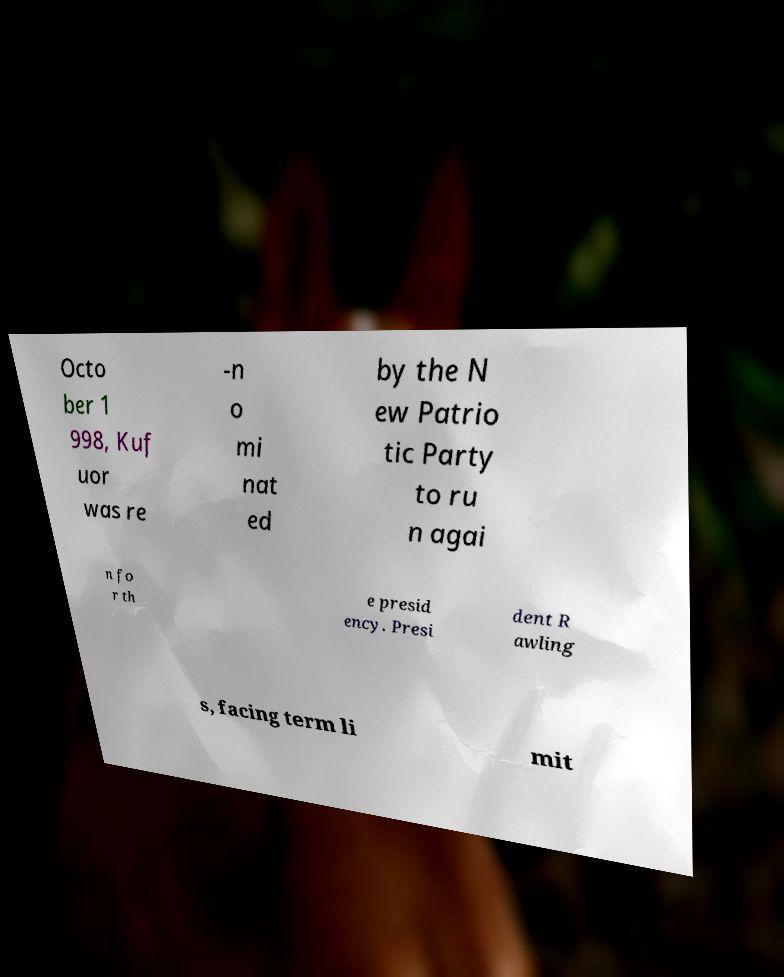Can you read and provide the text displayed in the image?This photo seems to have some interesting text. Can you extract and type it out for me? Octo ber 1 998, Kuf uor was re -n o mi nat ed by the N ew Patrio tic Party to ru n agai n fo r th e presid ency. Presi dent R awling s, facing term li mit 